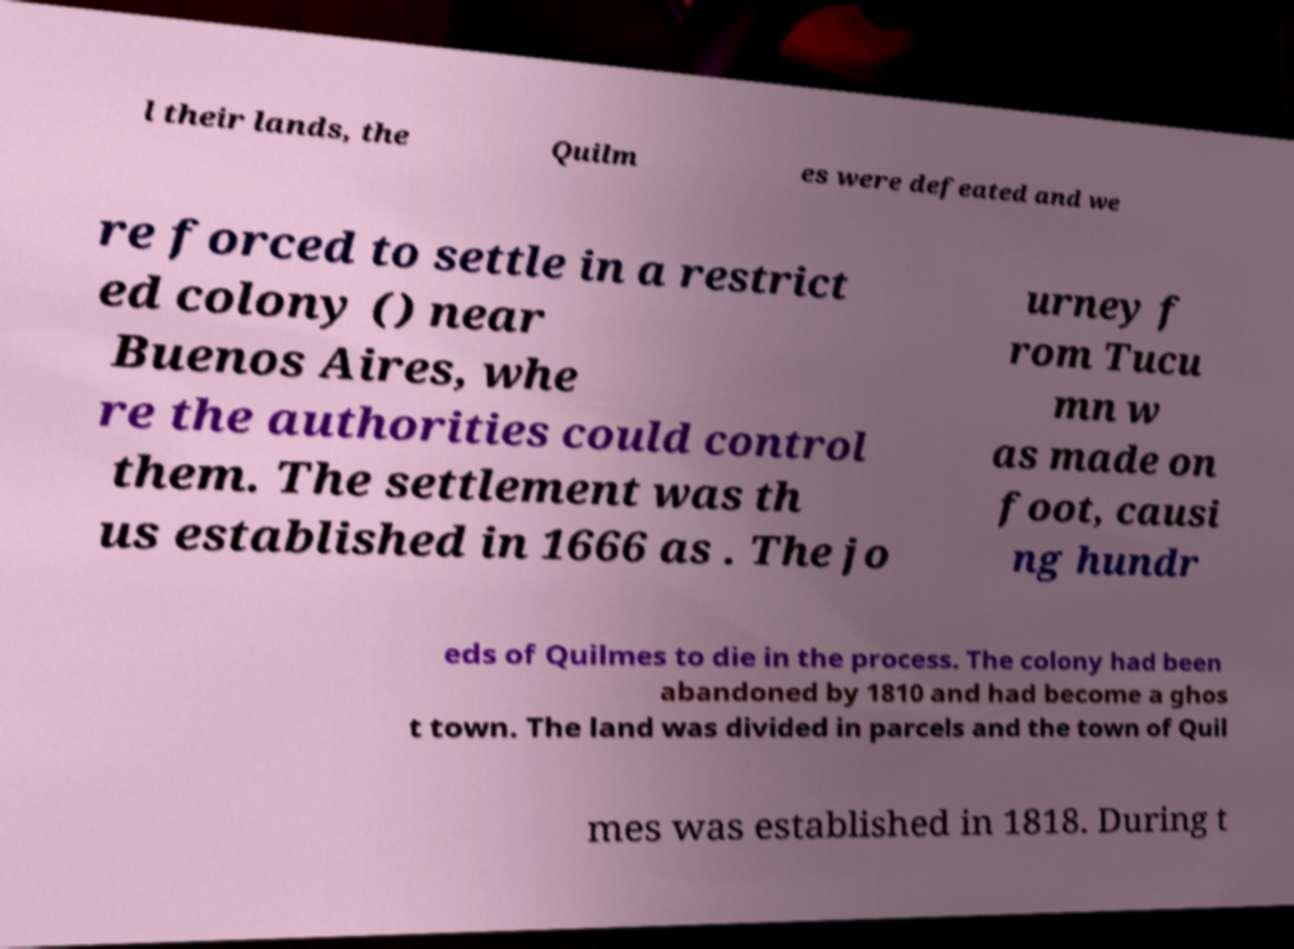Please identify and transcribe the text found in this image. l their lands, the Quilm es were defeated and we re forced to settle in a restrict ed colony () near Buenos Aires, whe re the authorities could control them. The settlement was th us established in 1666 as . The jo urney f rom Tucu mn w as made on foot, causi ng hundr eds of Quilmes to die in the process. The colony had been abandoned by 1810 and had become a ghos t town. The land was divided in parcels and the town of Quil mes was established in 1818. During t 